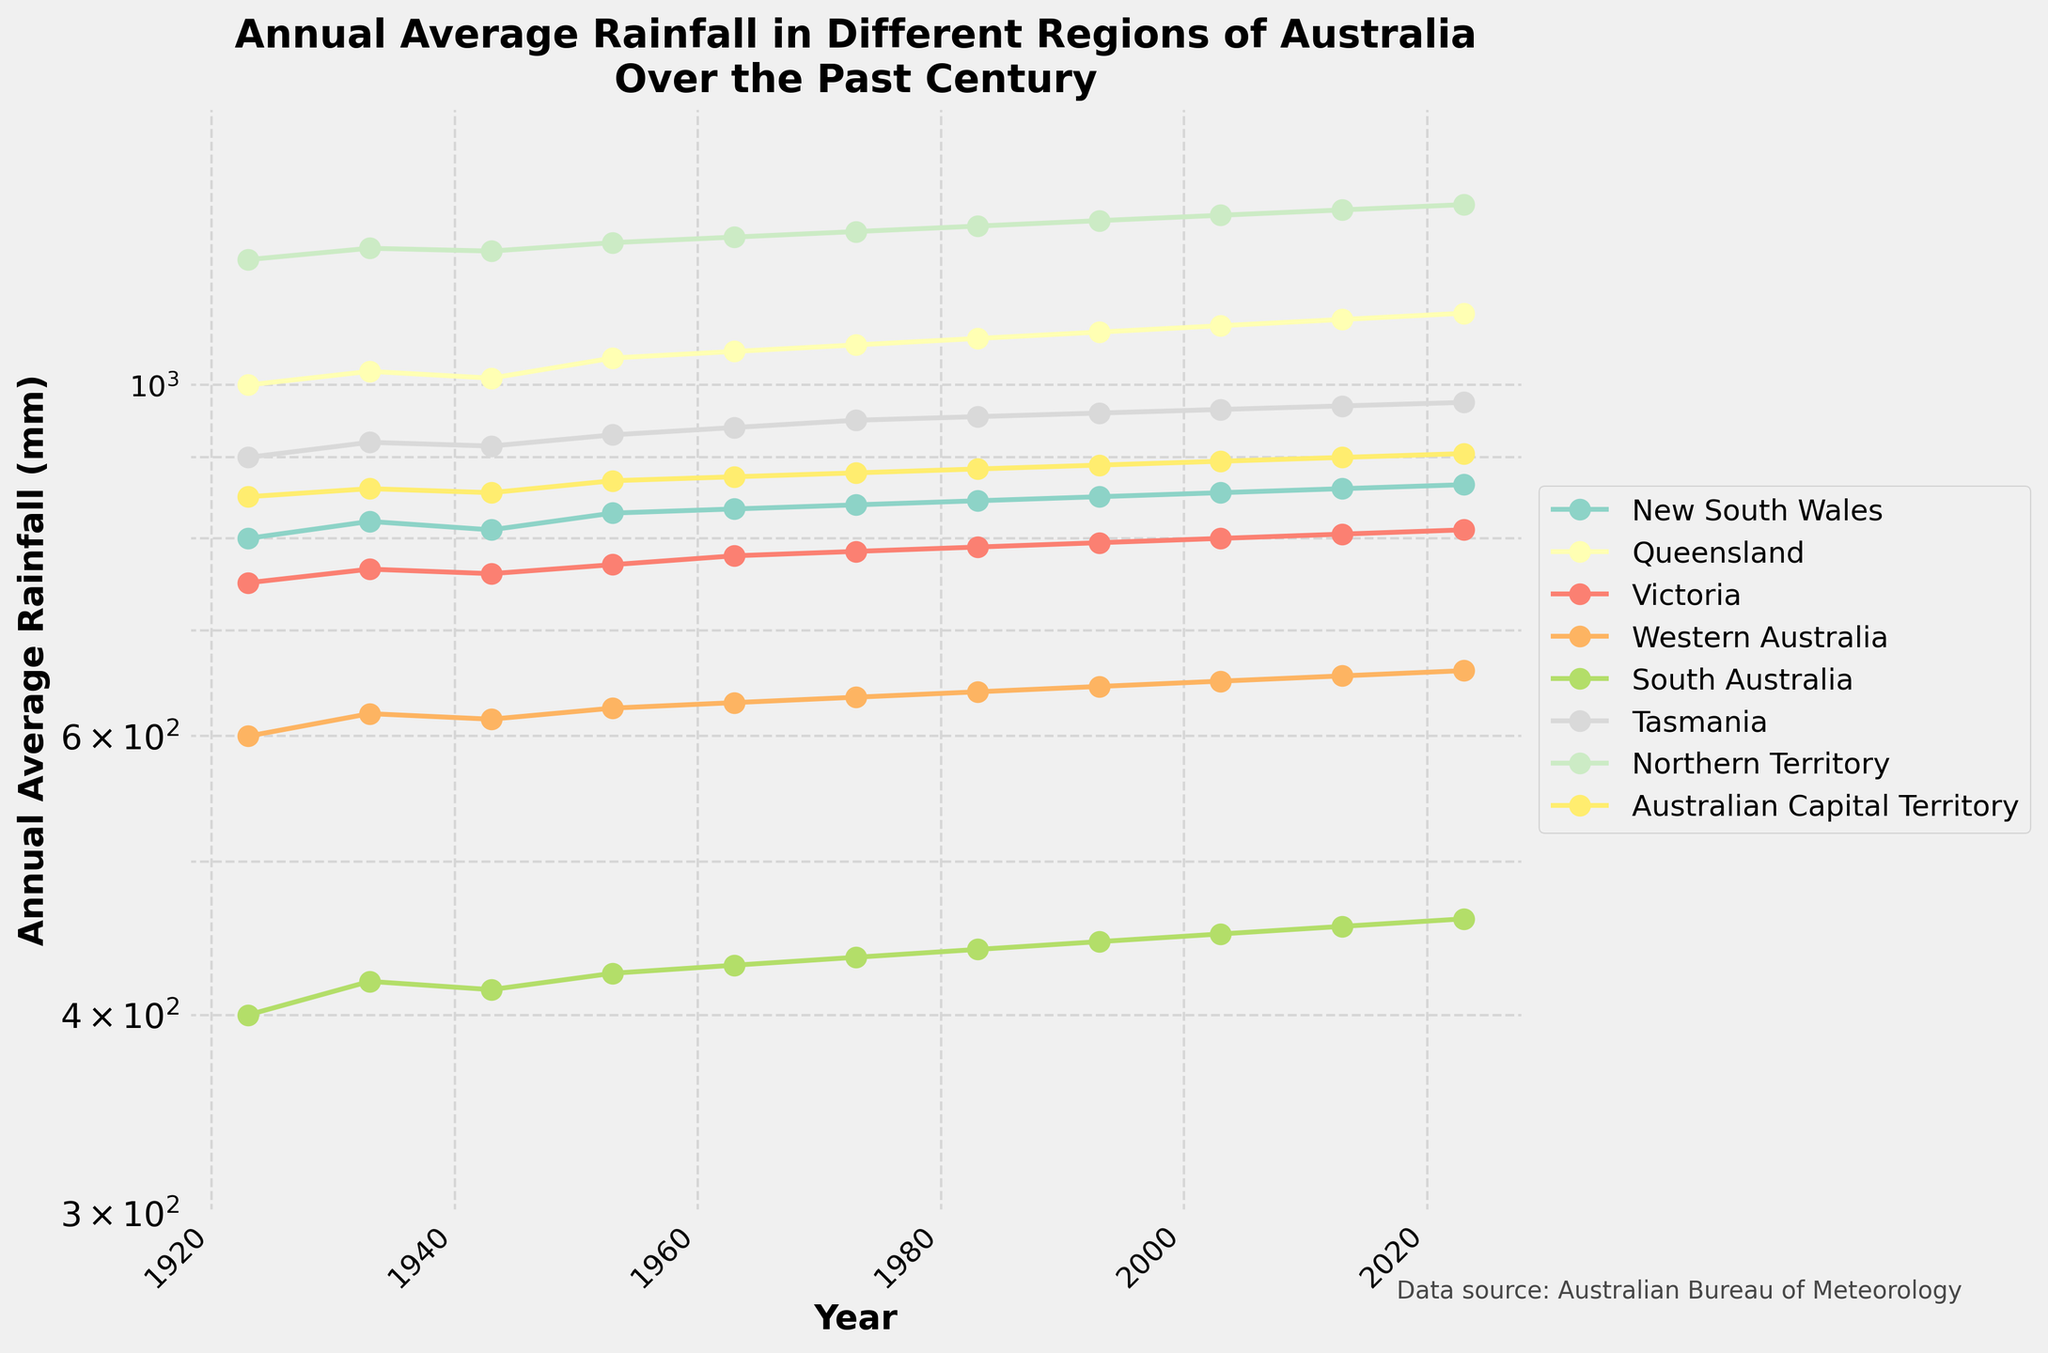What's the title of the figure? The title is usually displayed at the top of the figure. From the code, we can see that the title is set to 'Annual Average Rainfall in Different Regions of Australia\nOver the Past Century'.
Answer: Annual Average Rainfall in Different Regions of Australia Over the Past Century What is the lowest value on the y-axis? The y-axis in the plot is set on a log scale with the lower limit set to 300 mm.
Answer: 300 mm Which region had the highest annual average rainfall in 1923? The plot marks the data points for each region. By checking the starting year, 1923, for all regions, we see that Northern Territory has the highest value at 1200 mm.
Answer: Northern Territory Did the annual average rainfall for New South Wales increase or decrease from 1923 to 2023? By observing the plot, we can trace the line for New South Wales from 1923 to 2023. It shows an increasing trend from 800 mm to 865 mm.
Answer: Increase What is the range of annual average rainfall for Queensland from 1923 to 2023? To find the range, we look at the highest and lowest values for Queensland over the years. The lowest value is 1000 mm in 1923, and the highest value is 1110 mm in 2023. The range is 1110 - 1000 = 110 mm.
Answer: 110 mm Which regions have an annual average rainfall consistently above 600 mm across all years? By examining the plot, we can see that regions like New South Wales, Queensland, Victoria, Tasmania, Northern Territory, and Australian Capital Territory have consistently stayed above 600 mm.
Answer: New South Wales, Queensland, Victoria, Tasmania, Northern Territory, Australian Capital Territory How does the rainfall trend for South Australia compare to Western Australia over the century? Comparing the lines for South Australia and Western Australia, both show a gradual increase over the century, but South Australia consistently has lower values than Western Australia.
Answer: South Australia has lower values than Western Australia In which year did Tasmania's annual average rainfall cross 950 mm for the first time? By observing the line for Tasmania, it passes the 950 mm mark between 1973 and 1983. Therefore, the closest earlier year would be 1983.
Answer: 1983 What year had the most significant increase in rainfall for the Australian Capital Territory? By looking at the plot, we need to find the steepest upward line segment for the Australian Capital Territory. The segment between 2003 and 2013 shows the most significant increase from 895 mm to 900 mm.
Answer: Between 2003 and 2013 Has any region experienced a decrease in annual average rainfall over the century? Observing all the lines, all regions exhibit an increasing trend in rainfall, so none of the regions experienced a decrease over the century.
Answer: No 